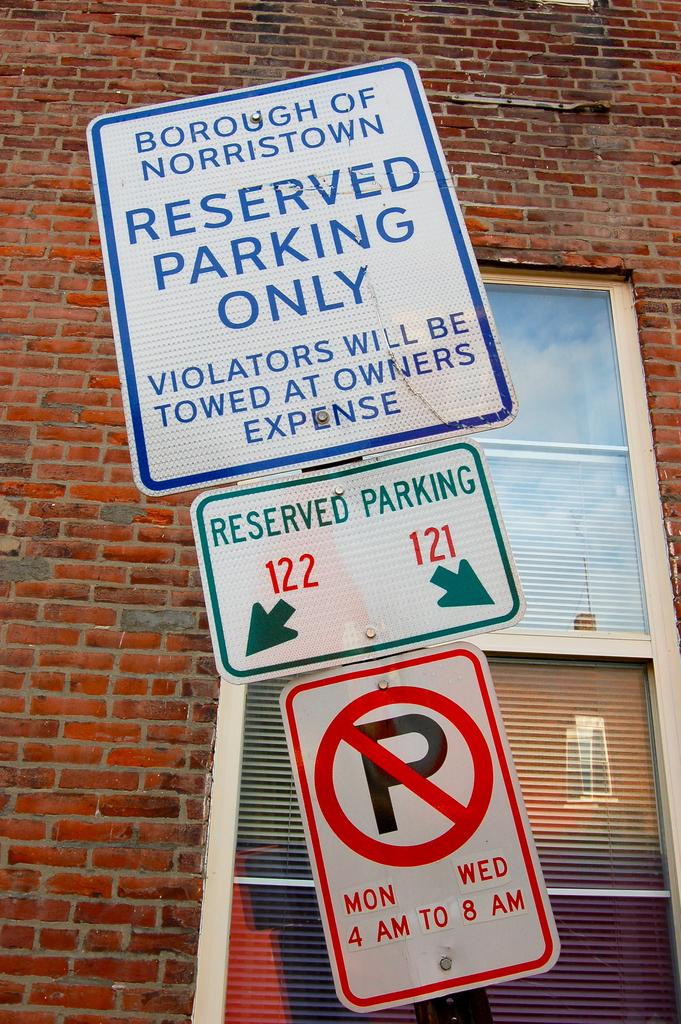<image>
Describe the image concisely. the word reserved that is on a sign 